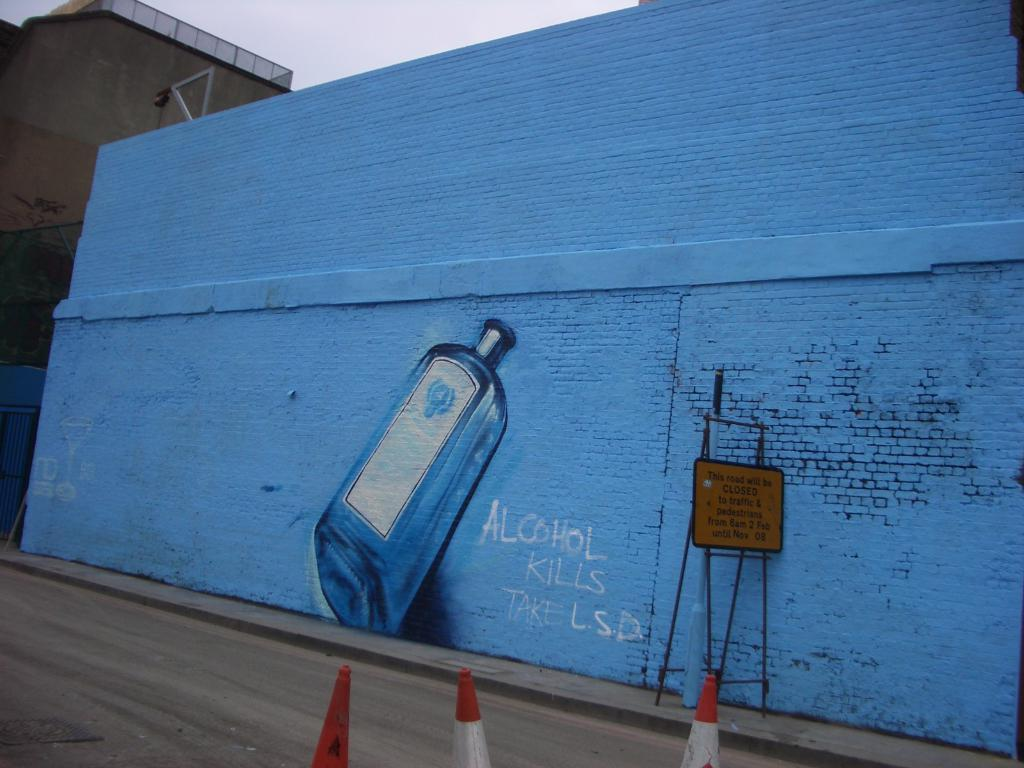<image>
Create a compact narrative representing the image presented. Blue wall saying "Alcohol Kills" and telling people to take LSD. 